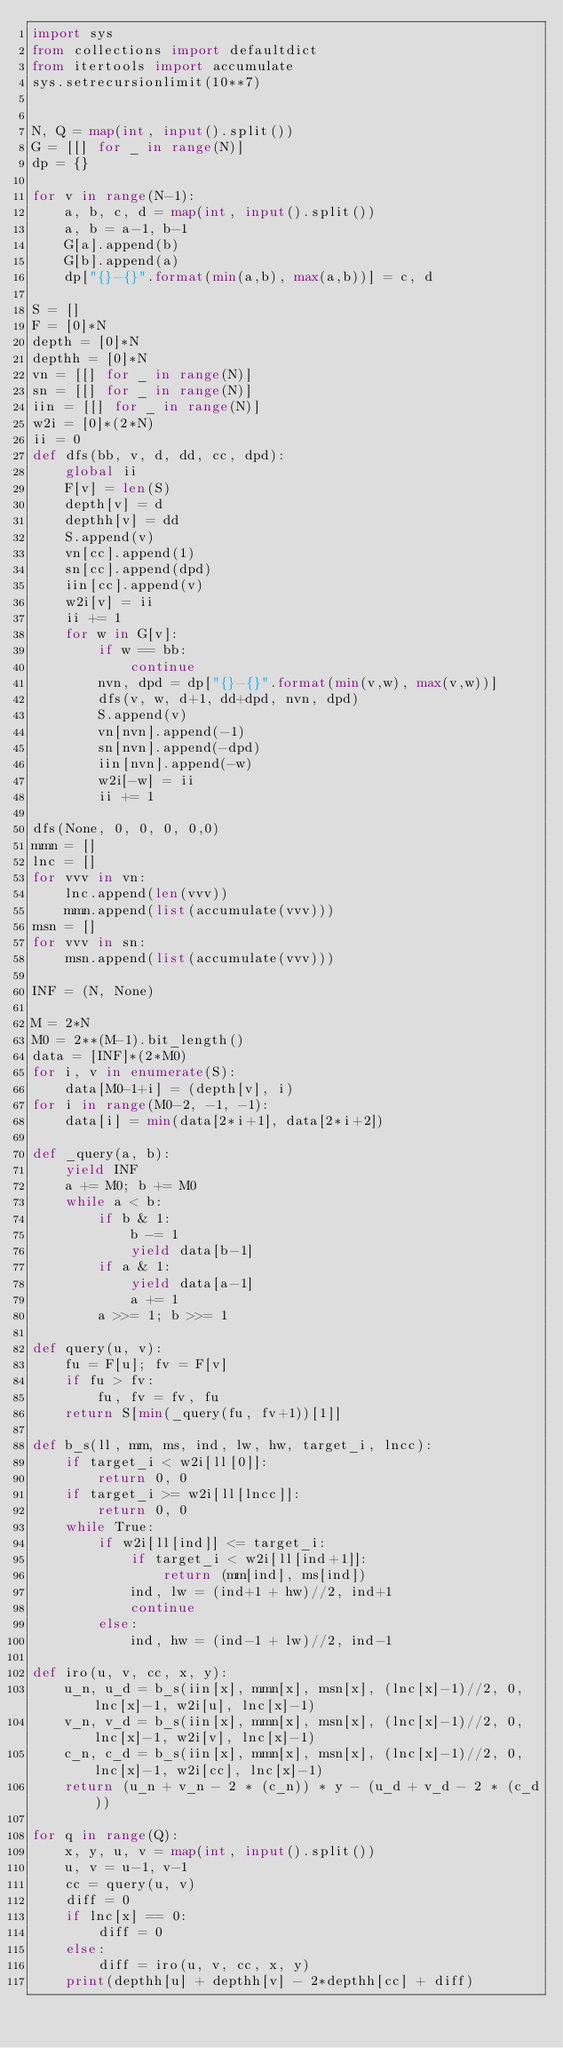<code> <loc_0><loc_0><loc_500><loc_500><_Python_>import sys
from collections import defaultdict
from itertools import accumulate
sys.setrecursionlimit(10**7)
 
 
N, Q = map(int, input().split())
G = [[] for _ in range(N)]
dp = {}

for v in range(N-1):
    a, b, c, d = map(int, input().split())
    a, b = a-1, b-1
    G[a].append(b)
    G[b].append(a)
    dp["{}-{}".format(min(a,b), max(a,b))] = c, d
 
S = []
F = [0]*N
depth = [0]*N
depthh = [0]*N
vn = [[] for _ in range(N)]
sn = [[] for _ in range(N)]
iin = [[] for _ in range(N)]
w2i = [0]*(2*N)
ii = 0
def dfs(bb, v, d, dd, cc, dpd):
    global ii
    F[v] = len(S)
    depth[v] = d
    depthh[v] = dd
    S.append(v)
    vn[cc].append(1)
    sn[cc].append(dpd)
    iin[cc].append(v)
    w2i[v] = ii
    ii += 1
    for w in G[v]:
        if w == bb:
            continue
        nvn, dpd = dp["{}-{}".format(min(v,w), max(v,w))]
        dfs(v, w, d+1, dd+dpd, nvn, dpd)
        S.append(v)
        vn[nvn].append(-1)
        sn[nvn].append(-dpd)
        iin[nvn].append(-w)
        w2i[-w] = ii
        ii += 1

dfs(None, 0, 0, 0, 0,0)
mmn = []
lnc = []
for vvv in vn:
    lnc.append(len(vvv))
    mmn.append(list(accumulate(vvv)))
msn = []
for vvv in sn:
    msn.append(list(accumulate(vvv)))
 
INF = (N, None)
 
M = 2*N
M0 = 2**(M-1).bit_length()
data = [INF]*(2*M0)
for i, v in enumerate(S):
    data[M0-1+i] = (depth[v], i)
for i in range(M0-2, -1, -1):
    data[i] = min(data[2*i+1], data[2*i+2])
 
def _query(a, b):
    yield INF
    a += M0; b += M0
    while a < b:
        if b & 1:
            b -= 1
            yield data[b-1]
        if a & 1:
            yield data[a-1]
            a += 1
        a >>= 1; b >>= 1
 
def query(u, v):
    fu = F[u]; fv = F[v]
    if fu > fv:
        fu, fv = fv, fu
    return S[min(_query(fu, fv+1))[1]]

def b_s(ll, mm, ms, ind, lw, hw, target_i, lncc):
    if target_i < w2i[ll[0]]:
        return 0, 0
    if target_i >= w2i[ll[lncc]]:
        return 0, 0
    while True:
        if w2i[ll[ind]] <= target_i:
            if target_i < w2i[ll[ind+1]]:
                return (mm[ind], ms[ind])
            ind, lw = (ind+1 + hw)//2, ind+1
            continue
        else:
            ind, hw = (ind-1 + lw)//2, ind-1

def iro(u, v, cc, x, y):
    u_n, u_d = b_s(iin[x], mmn[x], msn[x], (lnc[x]-1)//2, 0, lnc[x]-1, w2i[u], lnc[x]-1)
    v_n, v_d = b_s(iin[x], mmn[x], msn[x], (lnc[x]-1)//2, 0, lnc[x]-1, w2i[v], lnc[x]-1)
    c_n, c_d = b_s(iin[x], mmn[x], msn[x], (lnc[x]-1)//2, 0, lnc[x]-1, w2i[cc], lnc[x]-1)
    return (u_n + v_n - 2 * (c_n)) * y - (u_d + v_d - 2 * (c_d))

for q in range(Q):
    x, y, u, v = map(int, input().split())
    u, v = u-1, v-1
    cc = query(u, v)
    diff = 0
    if lnc[x] == 0:
        diff = 0
    else:
        diff = iro(u, v, cc, x, y)
    print(depthh[u] + depthh[v] - 2*depthh[cc] + diff)
</code> 